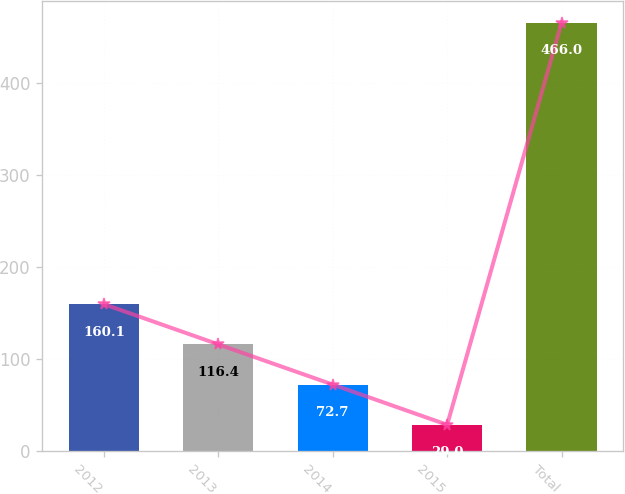Convert chart to OTSL. <chart><loc_0><loc_0><loc_500><loc_500><bar_chart><fcel>2012<fcel>2013<fcel>2014<fcel>2015<fcel>Total<nl><fcel>160.1<fcel>116.4<fcel>72.7<fcel>29<fcel>466<nl></chart> 